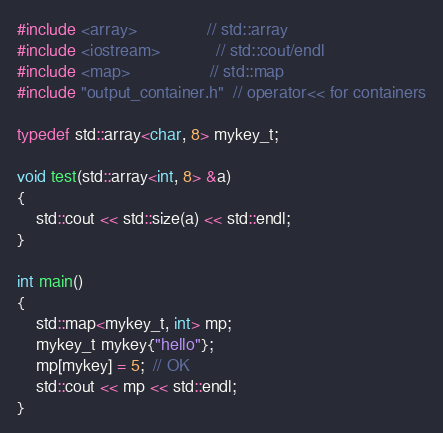Convert code to text. <code><loc_0><loc_0><loc_500><loc_500><_C++_>#include <array>               // std::array
#include <iostream>            // std::cout/endl
#include <map>                 // std::map
#include "output_container.h"  // operator<< for containers

typedef std::array<char, 8> mykey_t;

void test(std::array<int, 8> &a)
{
    std::cout << std::size(a) << std::endl;
}

int main()
{
    std::map<mykey_t, int> mp;
    mykey_t mykey{"hello"};
    mp[mykey] = 5;  // OK
    std::cout << mp << std::endl;
}
</code> 